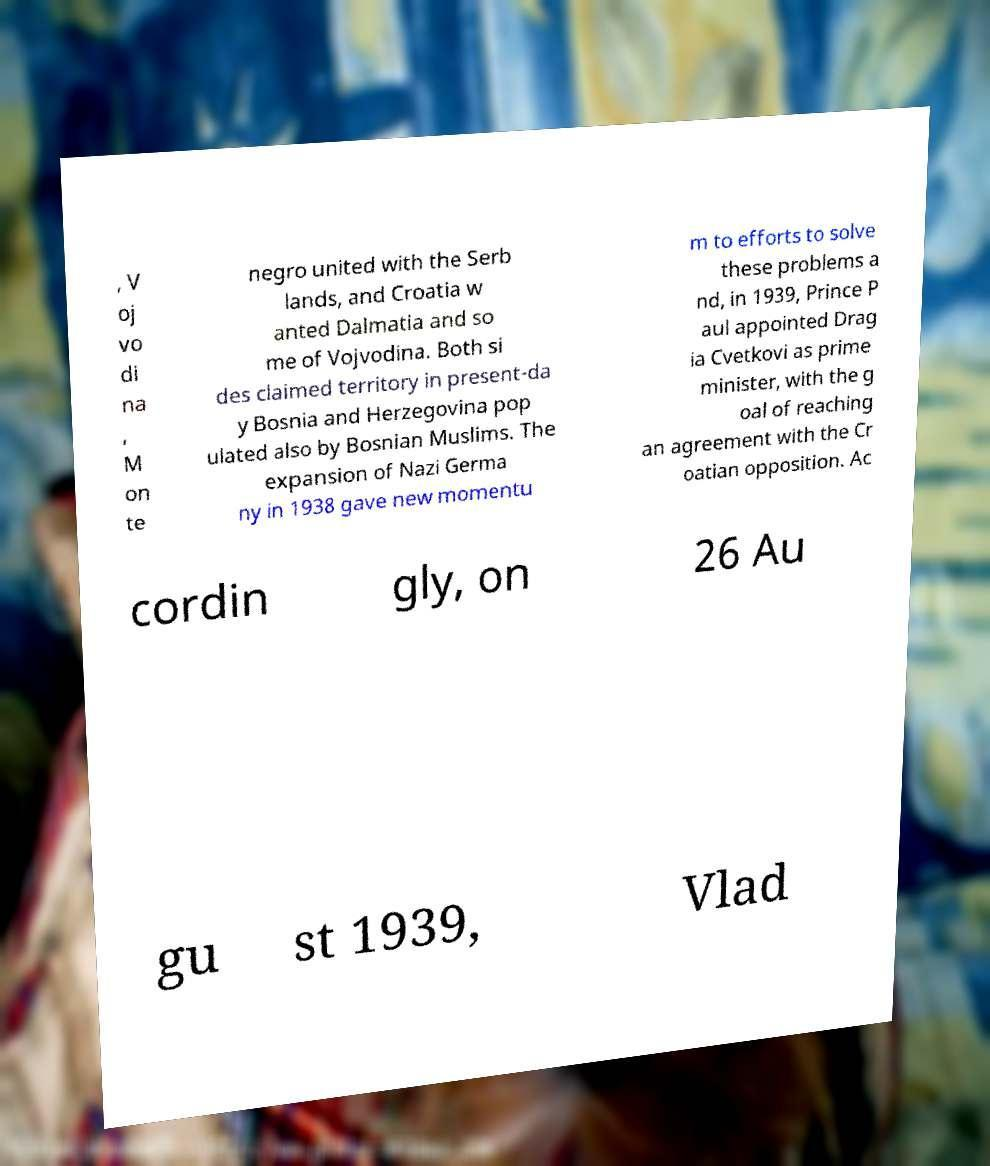There's text embedded in this image that I need extracted. Can you transcribe it verbatim? , V oj vo di na , M on te negro united with the Serb lands, and Croatia w anted Dalmatia and so me of Vojvodina. Both si des claimed territory in present-da y Bosnia and Herzegovina pop ulated also by Bosnian Muslims. The expansion of Nazi Germa ny in 1938 gave new momentu m to efforts to solve these problems a nd, in 1939, Prince P aul appointed Drag ia Cvetkovi as prime minister, with the g oal of reaching an agreement with the Cr oatian opposition. Ac cordin gly, on 26 Au gu st 1939, Vlad 